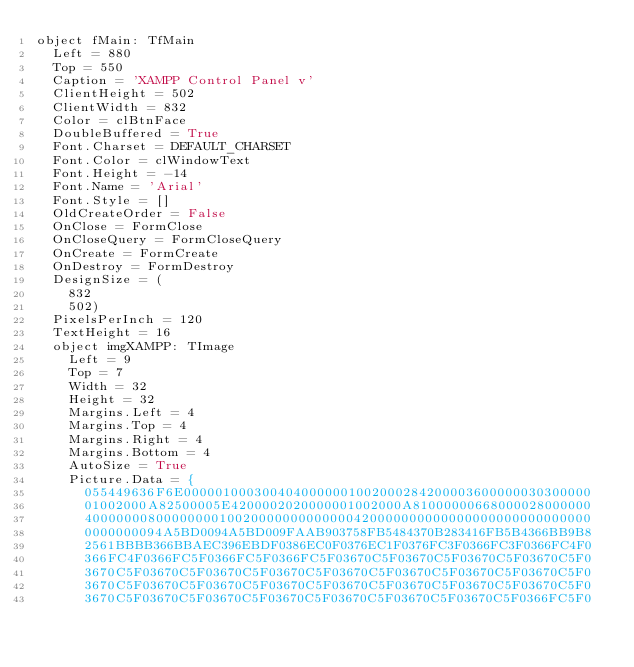<code> <loc_0><loc_0><loc_500><loc_500><_Pascal_>object fMain: TfMain
  Left = 880
  Top = 550
  Caption = 'XAMPP Control Panel v'
  ClientHeight = 502
  ClientWidth = 832
  Color = clBtnFace
  DoubleBuffered = True
  Font.Charset = DEFAULT_CHARSET
  Font.Color = clWindowText
  Font.Height = -14
  Font.Name = 'Arial'
  Font.Style = []
  OldCreateOrder = False
  OnClose = FormClose
  OnCloseQuery = FormCloseQuery
  OnCreate = FormCreate
  OnDestroy = FormDestroy
  DesignSize = (
    832
    502)
  PixelsPerInch = 120
  TextHeight = 16
  object imgXAMPP: TImage
    Left = 9
    Top = 7
    Width = 32
    Height = 32
    Margins.Left = 4
    Margins.Top = 4
    Margins.Right = 4
    Margins.Bottom = 4
    AutoSize = True
    Picture.Data = {
      055449636F6E0000010003004040000001002000284200003600000030300000
      01002000A82500005E4200002020000001002000A81000000668000028000000
      4000000080000000010020000000000000420000000000000000000000000000
      0000000094A5BD0094A5BD009FAAB903758FB5484370B283416FB5B4366BB9B8
      2561BBBB366BBAEC396EBDF0386EC0F0376EC1F0376FC3F0366FC3F0366FC4F0
      366FC4F0366FC5F0366FC5F0366FC5F03670C5F03670C5F03670C5F03670C5F0
      3670C5F03670C5F03670C5F03670C5F03670C5F03670C5F03670C5F03670C5F0
      3670C5F03670C5F03670C5F03670C5F03670C5F03670C5F03670C5F03670C5F0
      3670C5F03670C5F03670C5F03670C5F03670C5F03670C5F03670C5F0366FC5F0</code> 